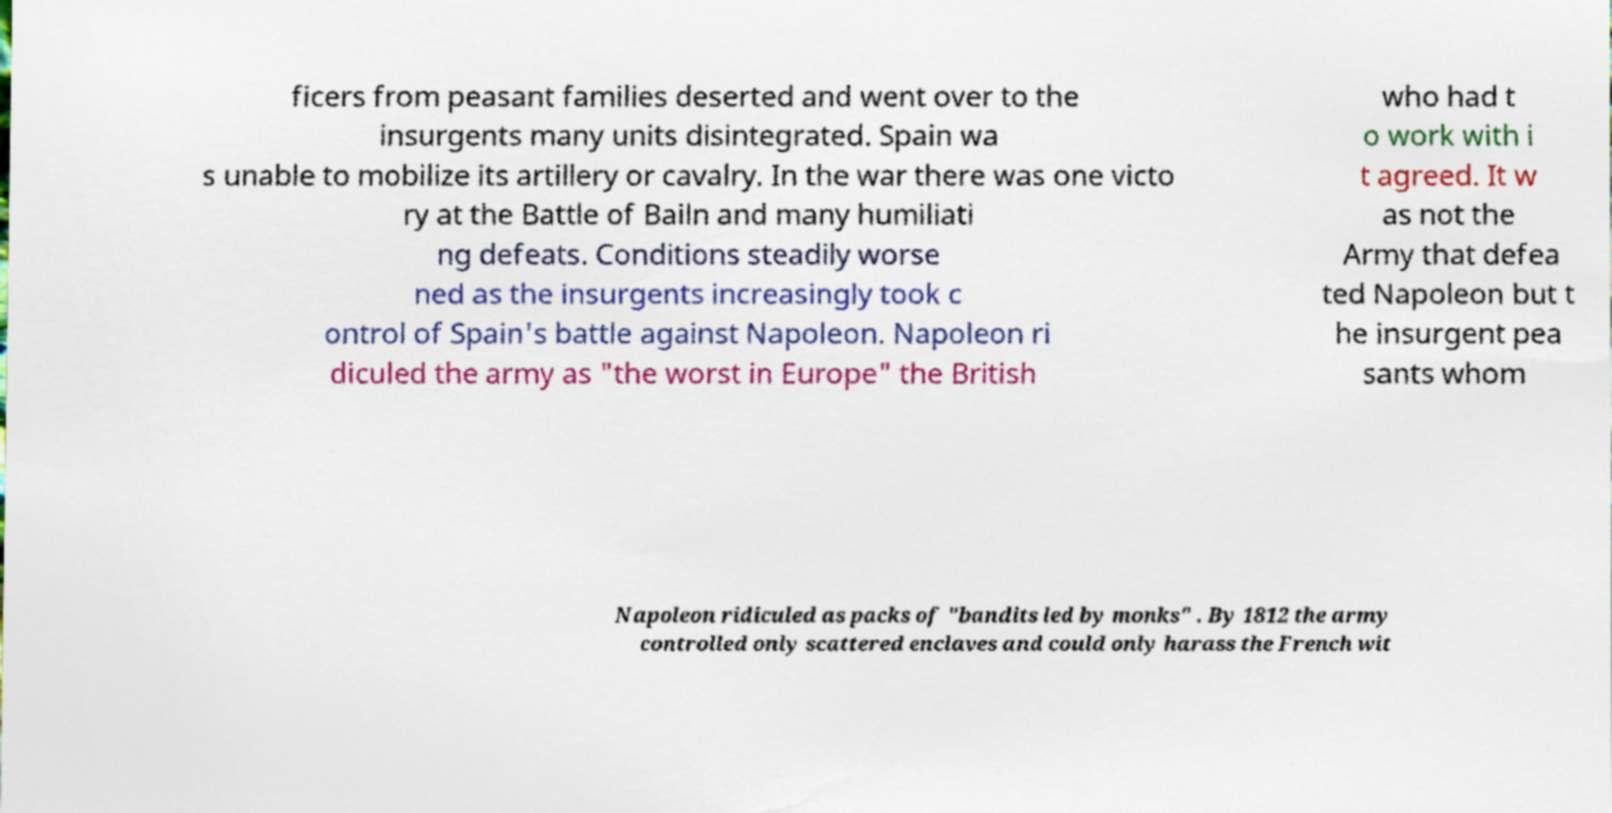Can you accurately transcribe the text from the provided image for me? ficers from peasant families deserted and went over to the insurgents many units disintegrated. Spain wa s unable to mobilize its artillery or cavalry. In the war there was one victo ry at the Battle of Bailn and many humiliati ng defeats. Conditions steadily worse ned as the insurgents increasingly took c ontrol of Spain's battle against Napoleon. Napoleon ri diculed the army as "the worst in Europe" the British who had t o work with i t agreed. It w as not the Army that defea ted Napoleon but t he insurgent pea sants whom Napoleon ridiculed as packs of "bandits led by monks" . By 1812 the army controlled only scattered enclaves and could only harass the French wit 